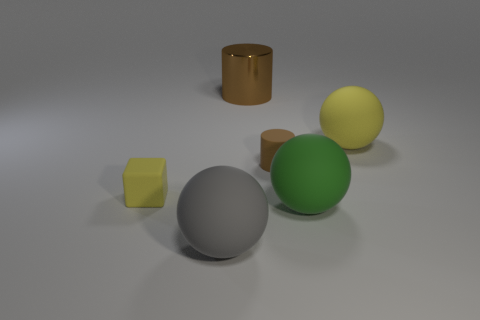Add 1 tiny brown matte cylinders. How many objects exist? 7 Subtract all cubes. How many objects are left? 5 Subtract all large purple shiny objects. Subtract all small matte objects. How many objects are left? 4 Add 2 matte cylinders. How many matte cylinders are left? 3 Add 2 tiny yellow shiny cubes. How many tiny yellow shiny cubes exist? 2 Subtract 0 purple cubes. How many objects are left? 6 